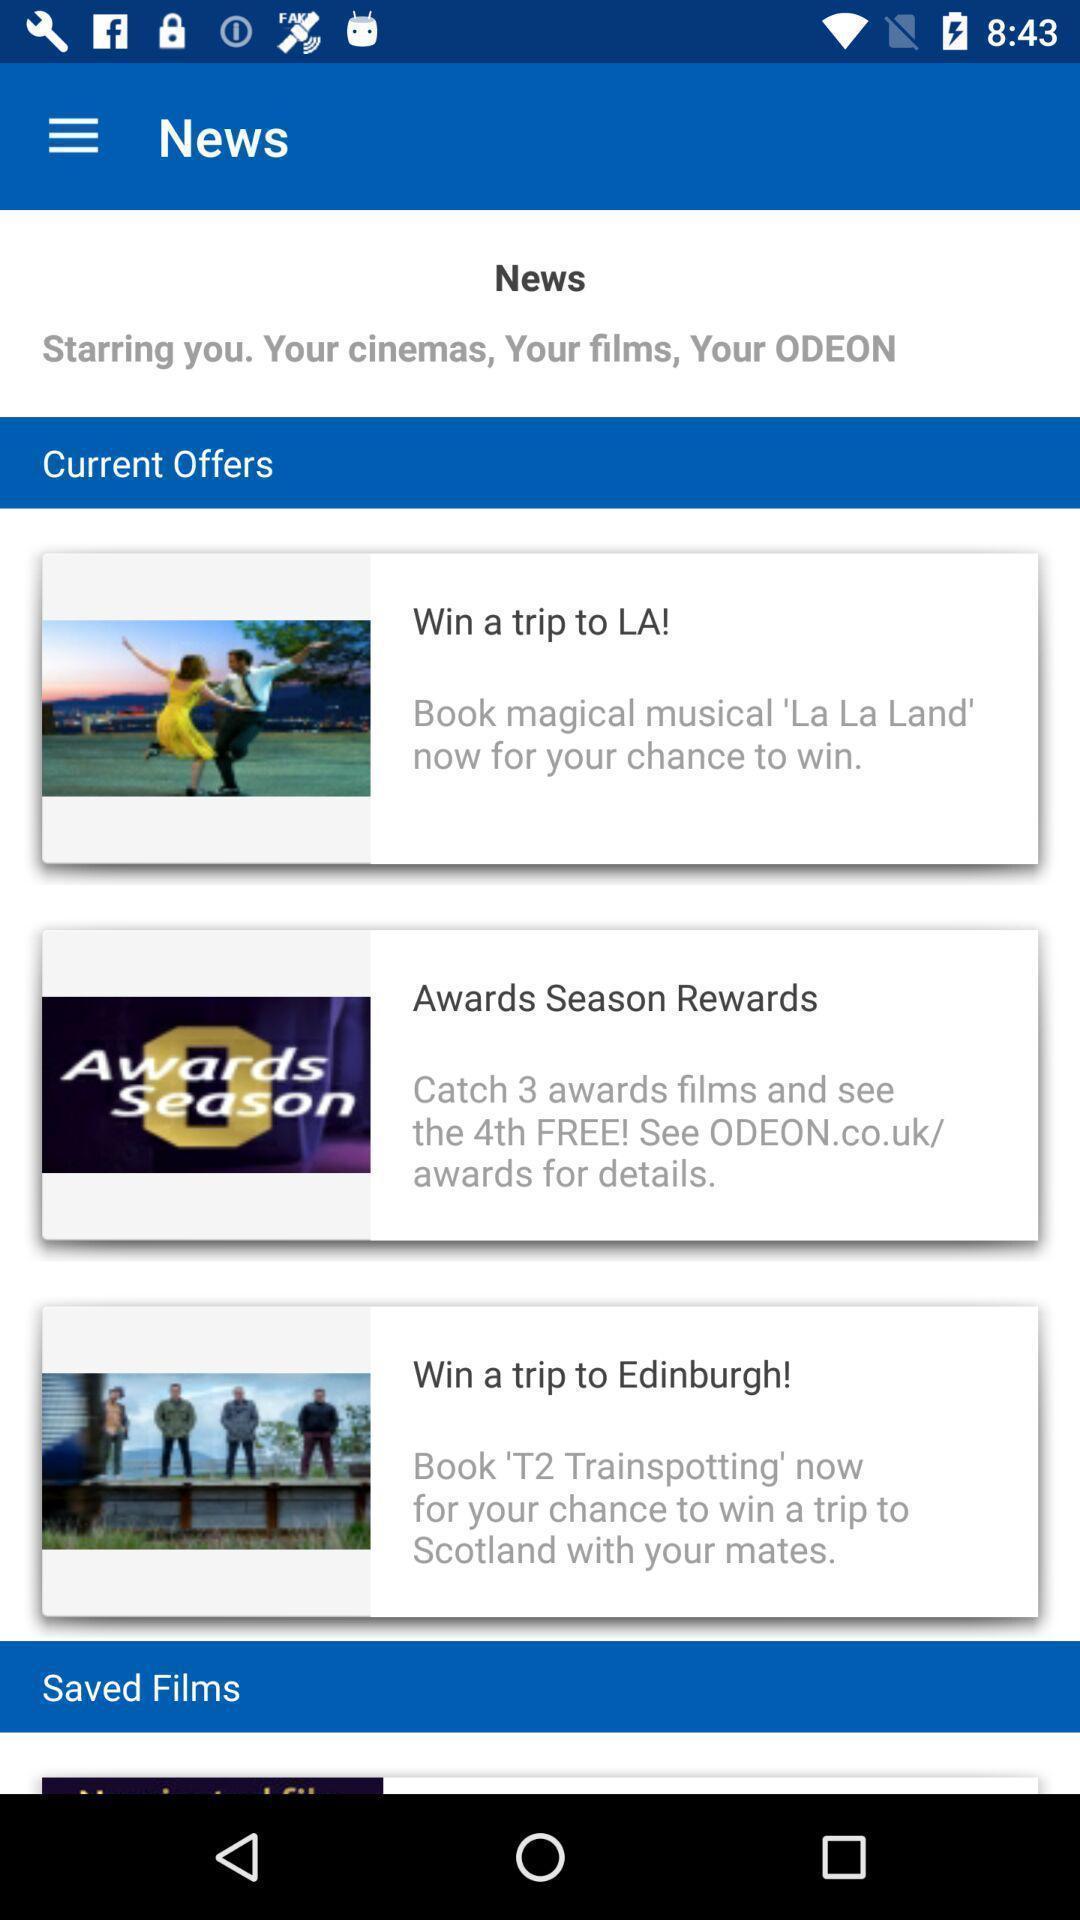Describe the content in this image. Screen showing news page of a social app. 